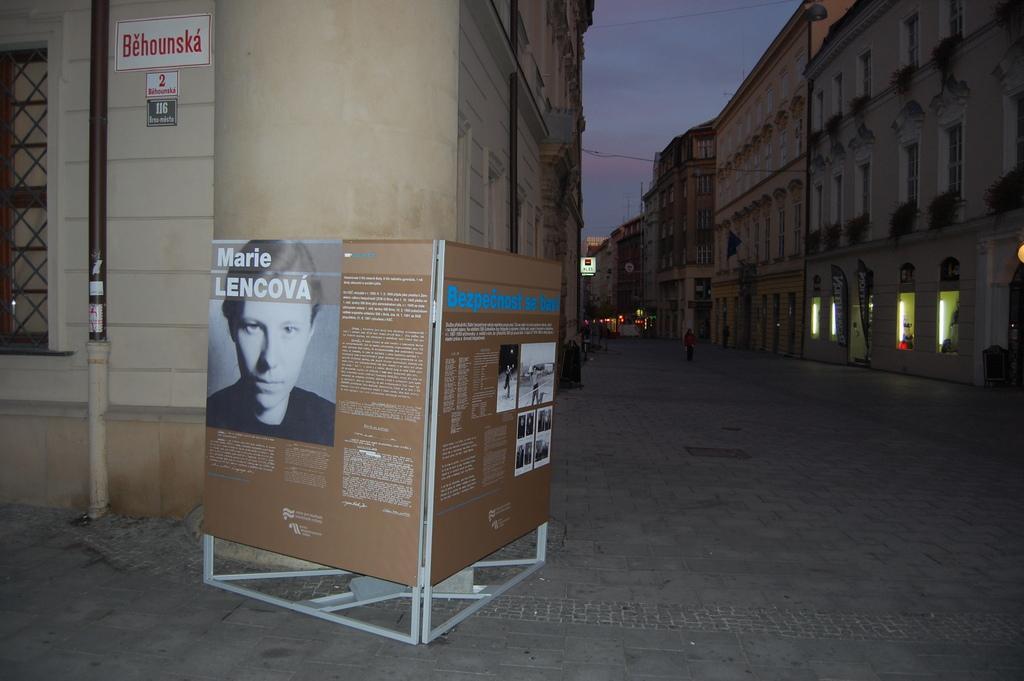Could you give a brief overview of what you see in this image? In this picture we can see two boards in the front, there are pictures and some text on these boards, on the right side and left side there are buildings, we can see a pipe and boards on the left side, there is the sky at the top of the picture. 